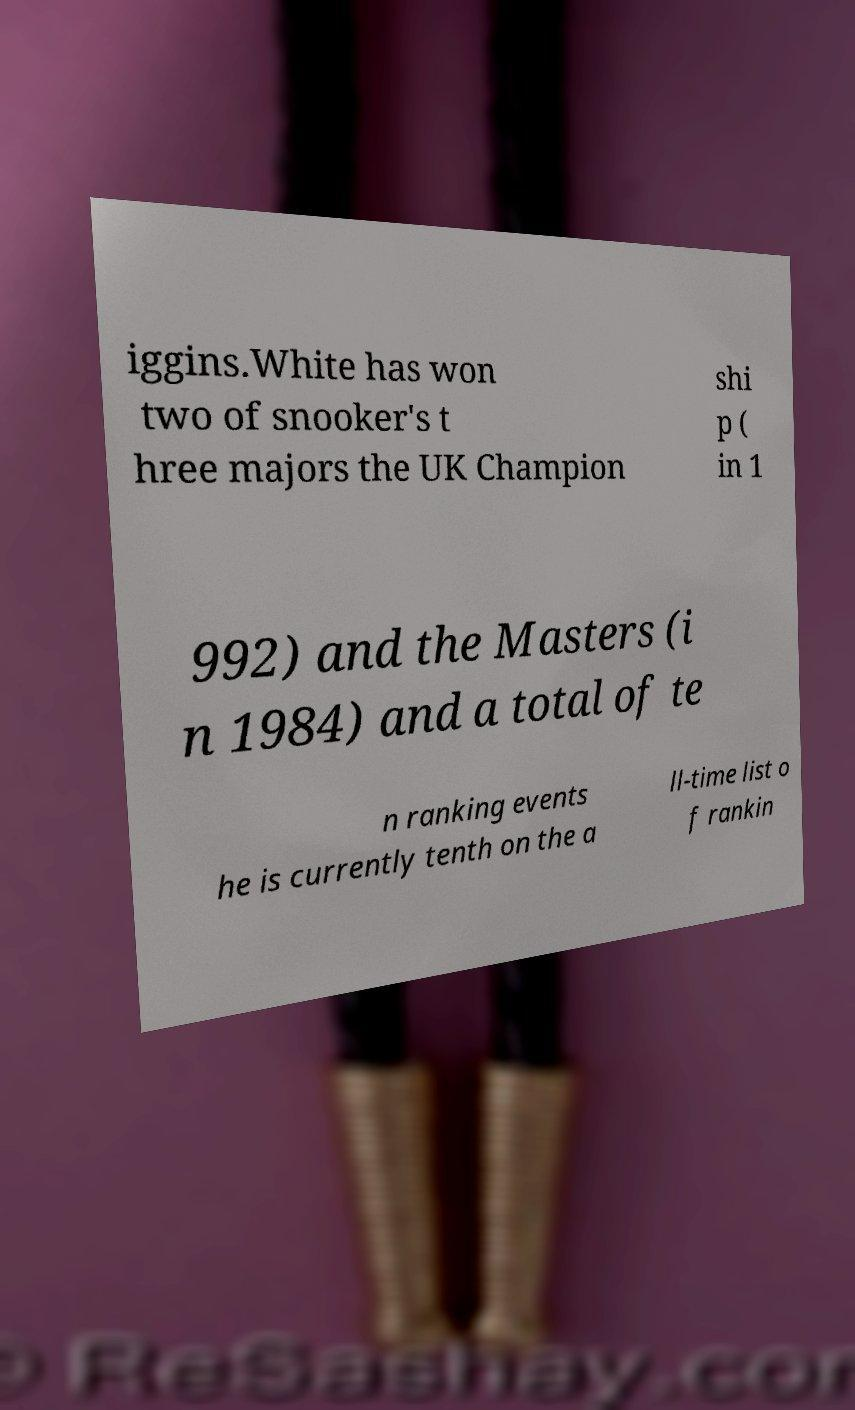I need the written content from this picture converted into text. Can you do that? iggins.White has won two of snooker's t hree majors the UK Champion shi p ( in 1 992) and the Masters (i n 1984) and a total of te n ranking events he is currently tenth on the a ll-time list o f rankin 